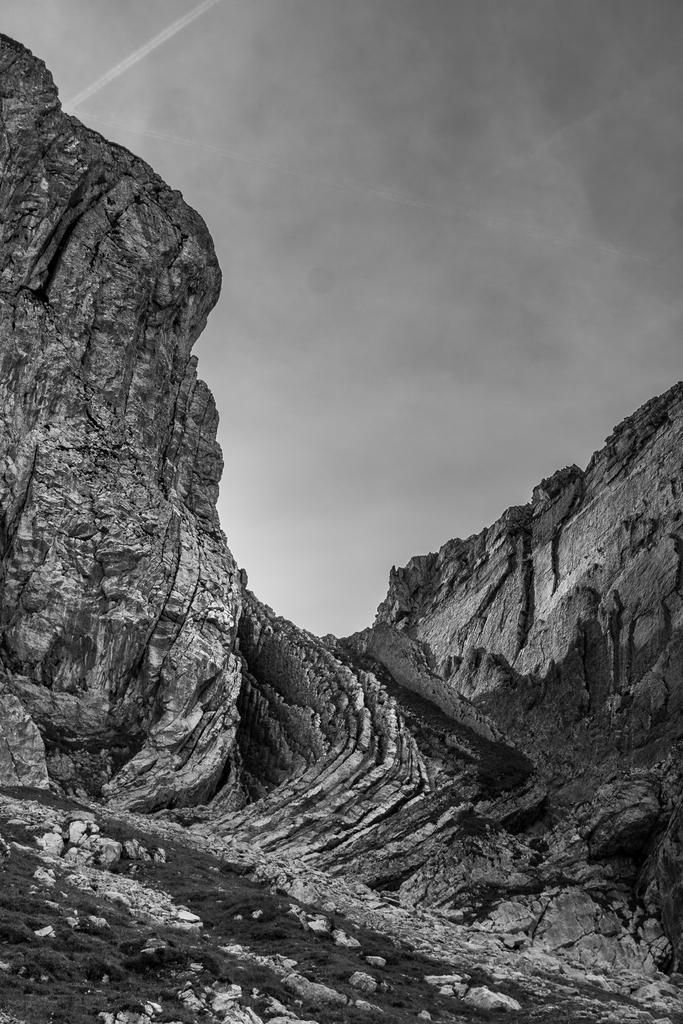What is the color scheme of the image? The image is black and white. What is the main feature in the image? There is a huge rock hill in the image. Is there any specific terrain feature in front of the rock hill? Yes, there is a sloped surface in front of the rock hill. How many chickens can be seen on the rock hill in the image? There are no chickens present in the image; it features a black and white image of a rock hill with a sloped surface in front of it. What type of club is visible on the rock hill in the image? There is no club present on the rock hill in the image. 